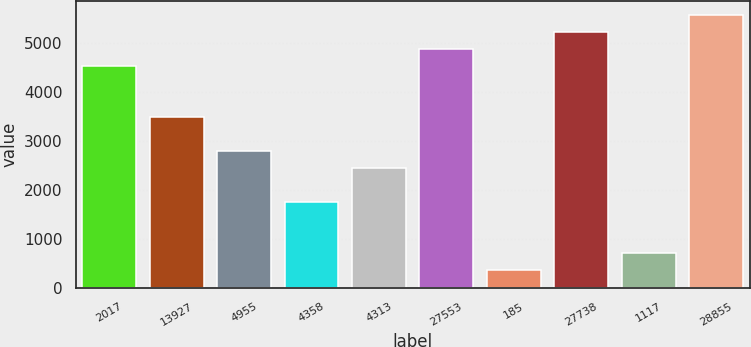Convert chart to OTSL. <chart><loc_0><loc_0><loc_500><loc_500><bar_chart><fcel>2017<fcel>13927<fcel>4955<fcel>4358<fcel>4313<fcel>27553<fcel>185<fcel>27738<fcel>1117<fcel>28855<nl><fcel>4525.92<fcel>3484.5<fcel>2790.22<fcel>1748.8<fcel>2443.08<fcel>4873.06<fcel>360.24<fcel>5220.2<fcel>707.38<fcel>5567.34<nl></chart> 